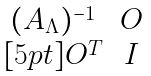Convert formula to latex. <formula><loc_0><loc_0><loc_500><loc_500>\begin{matrix} ( A _ { \Lambda } ) ^ { - 1 } & O \\ [ 5 p t ] O ^ { T } & I \end{matrix}</formula> 